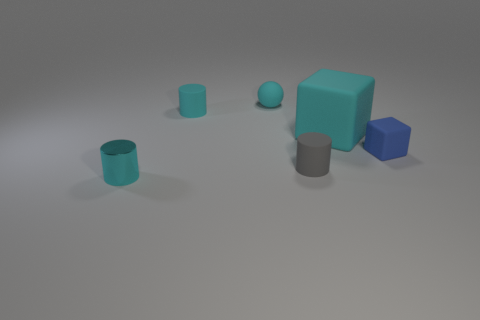Add 3 tiny gray matte objects. How many objects exist? 9 Subtract all balls. How many objects are left? 5 Subtract 0 green blocks. How many objects are left? 6 Subtract all large objects. Subtract all tiny brown things. How many objects are left? 5 Add 1 large objects. How many large objects are left? 2 Add 4 cyan rubber balls. How many cyan rubber balls exist? 5 